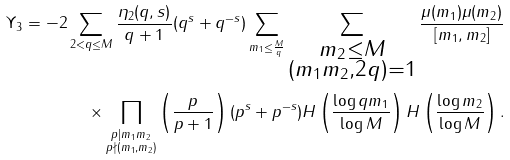<formula> <loc_0><loc_0><loc_500><loc_500>\Upsilon _ { 3 } = - 2 \sum _ { 2 < q \leq M } \frac { \eta _ { 2 } ( q , s ) } { q + 1 } ( q ^ { s } + q ^ { - s } ) \sum _ { m _ { 1 } \leq \frac { M } { q } } \sum _ { \substack { m _ { 2 } \leq M \\ ( m _ { 1 } m _ { 2 } , 2 q ) = 1 } } \frac { \mu ( m _ { 1 } ) \mu ( m _ { 2 } ) } { [ m _ { 1 } , m _ { 2 } ] } \\ \times \prod _ { \substack { p | m _ { 1 } m _ { 2 } \\ p \nmid ( m _ { 1 } , m _ { 2 } ) } } \left ( \frac { p } { p + 1 } \right ) ( p ^ { s } + p ^ { - s } ) H \left ( \frac { \log q m _ { 1 } } { \log M } \right ) H \left ( \frac { \log m _ { 2 } } { \log M } \right ) .</formula> 